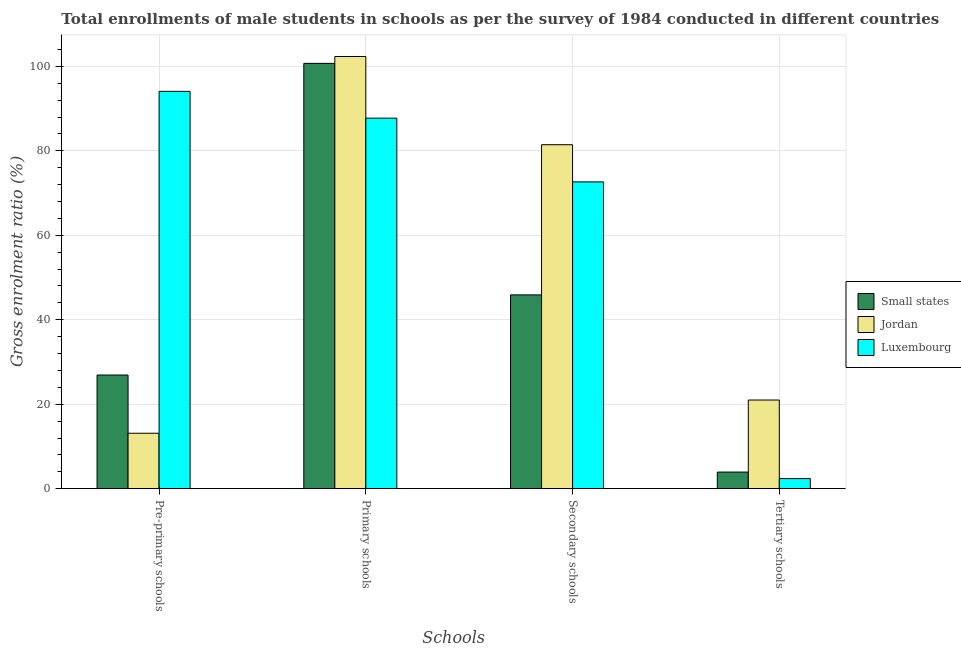How many groups of bars are there?
Give a very brief answer. 4. Are the number of bars per tick equal to the number of legend labels?
Provide a short and direct response. Yes. How many bars are there on the 4th tick from the left?
Provide a succinct answer. 3. How many bars are there on the 3rd tick from the right?
Offer a terse response. 3. What is the label of the 2nd group of bars from the left?
Your response must be concise. Primary schools. What is the gross enrolment ratio(male) in secondary schools in Luxembourg?
Provide a succinct answer. 72.65. Across all countries, what is the maximum gross enrolment ratio(male) in pre-primary schools?
Your response must be concise. 94.09. Across all countries, what is the minimum gross enrolment ratio(male) in primary schools?
Provide a succinct answer. 87.74. In which country was the gross enrolment ratio(male) in pre-primary schools maximum?
Make the answer very short. Luxembourg. In which country was the gross enrolment ratio(male) in primary schools minimum?
Provide a short and direct response. Luxembourg. What is the total gross enrolment ratio(male) in secondary schools in the graph?
Offer a very short reply. 199.99. What is the difference between the gross enrolment ratio(male) in pre-primary schools in Jordan and that in Small states?
Keep it short and to the point. -13.79. What is the difference between the gross enrolment ratio(male) in pre-primary schools in Small states and the gross enrolment ratio(male) in secondary schools in Jordan?
Your answer should be compact. -54.54. What is the average gross enrolment ratio(male) in primary schools per country?
Ensure brevity in your answer.  96.94. What is the difference between the gross enrolment ratio(male) in primary schools and gross enrolment ratio(male) in secondary schools in Small states?
Keep it short and to the point. 54.82. In how many countries, is the gross enrolment ratio(male) in primary schools greater than 4 %?
Give a very brief answer. 3. What is the ratio of the gross enrolment ratio(male) in secondary schools in Luxembourg to that in Small states?
Your response must be concise. 1.58. Is the difference between the gross enrolment ratio(male) in tertiary schools in Luxembourg and Jordan greater than the difference between the gross enrolment ratio(male) in secondary schools in Luxembourg and Jordan?
Your response must be concise. No. What is the difference between the highest and the second highest gross enrolment ratio(male) in pre-primary schools?
Your answer should be compact. 67.18. What is the difference between the highest and the lowest gross enrolment ratio(male) in secondary schools?
Give a very brief answer. 35.56. Is it the case that in every country, the sum of the gross enrolment ratio(male) in pre-primary schools and gross enrolment ratio(male) in secondary schools is greater than the sum of gross enrolment ratio(male) in primary schools and gross enrolment ratio(male) in tertiary schools?
Keep it short and to the point. No. What does the 1st bar from the left in Primary schools represents?
Offer a terse response. Small states. What does the 2nd bar from the right in Tertiary schools represents?
Your answer should be compact. Jordan. Is it the case that in every country, the sum of the gross enrolment ratio(male) in pre-primary schools and gross enrolment ratio(male) in primary schools is greater than the gross enrolment ratio(male) in secondary schools?
Make the answer very short. Yes. Are the values on the major ticks of Y-axis written in scientific E-notation?
Provide a succinct answer. No. Does the graph contain grids?
Keep it short and to the point. Yes. How are the legend labels stacked?
Your answer should be compact. Vertical. What is the title of the graph?
Your answer should be compact. Total enrollments of male students in schools as per the survey of 1984 conducted in different countries. What is the label or title of the X-axis?
Make the answer very short. Schools. What is the label or title of the Y-axis?
Make the answer very short. Gross enrolment ratio (%). What is the Gross enrolment ratio (%) in Small states in Pre-primary schools?
Make the answer very short. 26.91. What is the Gross enrolment ratio (%) of Jordan in Pre-primary schools?
Your answer should be very brief. 13.13. What is the Gross enrolment ratio (%) in Luxembourg in Pre-primary schools?
Give a very brief answer. 94.09. What is the Gross enrolment ratio (%) in Small states in Primary schools?
Provide a short and direct response. 100.71. What is the Gross enrolment ratio (%) of Jordan in Primary schools?
Give a very brief answer. 102.35. What is the Gross enrolment ratio (%) of Luxembourg in Primary schools?
Give a very brief answer. 87.74. What is the Gross enrolment ratio (%) in Small states in Secondary schools?
Your response must be concise. 45.89. What is the Gross enrolment ratio (%) in Jordan in Secondary schools?
Keep it short and to the point. 81.45. What is the Gross enrolment ratio (%) of Luxembourg in Secondary schools?
Give a very brief answer. 72.65. What is the Gross enrolment ratio (%) of Small states in Tertiary schools?
Your answer should be compact. 3.93. What is the Gross enrolment ratio (%) of Jordan in Tertiary schools?
Offer a terse response. 21. What is the Gross enrolment ratio (%) in Luxembourg in Tertiary schools?
Give a very brief answer. 2.39. Across all Schools, what is the maximum Gross enrolment ratio (%) of Small states?
Ensure brevity in your answer.  100.71. Across all Schools, what is the maximum Gross enrolment ratio (%) of Jordan?
Offer a very short reply. 102.35. Across all Schools, what is the maximum Gross enrolment ratio (%) of Luxembourg?
Ensure brevity in your answer.  94.09. Across all Schools, what is the minimum Gross enrolment ratio (%) in Small states?
Your answer should be very brief. 3.93. Across all Schools, what is the minimum Gross enrolment ratio (%) in Jordan?
Make the answer very short. 13.13. Across all Schools, what is the minimum Gross enrolment ratio (%) in Luxembourg?
Your answer should be compact. 2.39. What is the total Gross enrolment ratio (%) of Small states in the graph?
Give a very brief answer. 177.45. What is the total Gross enrolment ratio (%) in Jordan in the graph?
Provide a succinct answer. 217.92. What is the total Gross enrolment ratio (%) in Luxembourg in the graph?
Your answer should be very brief. 256.87. What is the difference between the Gross enrolment ratio (%) in Small states in Pre-primary schools and that in Primary schools?
Make the answer very short. -73.8. What is the difference between the Gross enrolment ratio (%) in Jordan in Pre-primary schools and that in Primary schools?
Provide a short and direct response. -89.22. What is the difference between the Gross enrolment ratio (%) in Luxembourg in Pre-primary schools and that in Primary schools?
Your answer should be compact. 6.35. What is the difference between the Gross enrolment ratio (%) in Small states in Pre-primary schools and that in Secondary schools?
Make the answer very short. -18.98. What is the difference between the Gross enrolment ratio (%) in Jordan in Pre-primary schools and that in Secondary schools?
Offer a very short reply. -68.33. What is the difference between the Gross enrolment ratio (%) in Luxembourg in Pre-primary schools and that in Secondary schools?
Offer a very short reply. 21.44. What is the difference between the Gross enrolment ratio (%) of Small states in Pre-primary schools and that in Tertiary schools?
Your answer should be very brief. 22.98. What is the difference between the Gross enrolment ratio (%) of Jordan in Pre-primary schools and that in Tertiary schools?
Your response must be concise. -7.87. What is the difference between the Gross enrolment ratio (%) of Luxembourg in Pre-primary schools and that in Tertiary schools?
Provide a succinct answer. 91.7. What is the difference between the Gross enrolment ratio (%) of Small states in Primary schools and that in Secondary schools?
Your response must be concise. 54.82. What is the difference between the Gross enrolment ratio (%) of Jordan in Primary schools and that in Secondary schools?
Provide a short and direct response. 20.89. What is the difference between the Gross enrolment ratio (%) in Luxembourg in Primary schools and that in Secondary schools?
Keep it short and to the point. 15.1. What is the difference between the Gross enrolment ratio (%) of Small states in Primary schools and that in Tertiary schools?
Your answer should be compact. 96.78. What is the difference between the Gross enrolment ratio (%) in Jordan in Primary schools and that in Tertiary schools?
Keep it short and to the point. 81.35. What is the difference between the Gross enrolment ratio (%) of Luxembourg in Primary schools and that in Tertiary schools?
Your answer should be compact. 85.36. What is the difference between the Gross enrolment ratio (%) in Small states in Secondary schools and that in Tertiary schools?
Offer a very short reply. 41.96. What is the difference between the Gross enrolment ratio (%) in Jordan in Secondary schools and that in Tertiary schools?
Offer a terse response. 60.46. What is the difference between the Gross enrolment ratio (%) in Luxembourg in Secondary schools and that in Tertiary schools?
Provide a succinct answer. 70.26. What is the difference between the Gross enrolment ratio (%) in Small states in Pre-primary schools and the Gross enrolment ratio (%) in Jordan in Primary schools?
Make the answer very short. -75.43. What is the difference between the Gross enrolment ratio (%) of Small states in Pre-primary schools and the Gross enrolment ratio (%) of Luxembourg in Primary schools?
Provide a succinct answer. -60.83. What is the difference between the Gross enrolment ratio (%) of Jordan in Pre-primary schools and the Gross enrolment ratio (%) of Luxembourg in Primary schools?
Make the answer very short. -74.62. What is the difference between the Gross enrolment ratio (%) of Small states in Pre-primary schools and the Gross enrolment ratio (%) of Jordan in Secondary schools?
Make the answer very short. -54.54. What is the difference between the Gross enrolment ratio (%) of Small states in Pre-primary schools and the Gross enrolment ratio (%) of Luxembourg in Secondary schools?
Your answer should be compact. -45.73. What is the difference between the Gross enrolment ratio (%) in Jordan in Pre-primary schools and the Gross enrolment ratio (%) in Luxembourg in Secondary schools?
Your answer should be compact. -59.52. What is the difference between the Gross enrolment ratio (%) in Small states in Pre-primary schools and the Gross enrolment ratio (%) in Jordan in Tertiary schools?
Make the answer very short. 5.92. What is the difference between the Gross enrolment ratio (%) in Small states in Pre-primary schools and the Gross enrolment ratio (%) in Luxembourg in Tertiary schools?
Give a very brief answer. 24.53. What is the difference between the Gross enrolment ratio (%) of Jordan in Pre-primary schools and the Gross enrolment ratio (%) of Luxembourg in Tertiary schools?
Offer a very short reply. 10.74. What is the difference between the Gross enrolment ratio (%) of Small states in Primary schools and the Gross enrolment ratio (%) of Jordan in Secondary schools?
Ensure brevity in your answer.  19.26. What is the difference between the Gross enrolment ratio (%) in Small states in Primary schools and the Gross enrolment ratio (%) in Luxembourg in Secondary schools?
Your answer should be compact. 28.06. What is the difference between the Gross enrolment ratio (%) in Jordan in Primary schools and the Gross enrolment ratio (%) in Luxembourg in Secondary schools?
Your answer should be compact. 29.7. What is the difference between the Gross enrolment ratio (%) in Small states in Primary schools and the Gross enrolment ratio (%) in Jordan in Tertiary schools?
Your answer should be very brief. 79.72. What is the difference between the Gross enrolment ratio (%) of Small states in Primary schools and the Gross enrolment ratio (%) of Luxembourg in Tertiary schools?
Ensure brevity in your answer.  98.33. What is the difference between the Gross enrolment ratio (%) in Jordan in Primary schools and the Gross enrolment ratio (%) in Luxembourg in Tertiary schools?
Ensure brevity in your answer.  99.96. What is the difference between the Gross enrolment ratio (%) in Small states in Secondary schools and the Gross enrolment ratio (%) in Jordan in Tertiary schools?
Offer a very short reply. 24.9. What is the difference between the Gross enrolment ratio (%) of Small states in Secondary schools and the Gross enrolment ratio (%) of Luxembourg in Tertiary schools?
Ensure brevity in your answer.  43.5. What is the difference between the Gross enrolment ratio (%) of Jordan in Secondary schools and the Gross enrolment ratio (%) of Luxembourg in Tertiary schools?
Offer a very short reply. 79.07. What is the average Gross enrolment ratio (%) of Small states per Schools?
Offer a very short reply. 44.36. What is the average Gross enrolment ratio (%) of Jordan per Schools?
Offer a terse response. 54.48. What is the average Gross enrolment ratio (%) in Luxembourg per Schools?
Give a very brief answer. 64.22. What is the difference between the Gross enrolment ratio (%) in Small states and Gross enrolment ratio (%) in Jordan in Pre-primary schools?
Make the answer very short. 13.79. What is the difference between the Gross enrolment ratio (%) of Small states and Gross enrolment ratio (%) of Luxembourg in Pre-primary schools?
Keep it short and to the point. -67.18. What is the difference between the Gross enrolment ratio (%) of Jordan and Gross enrolment ratio (%) of Luxembourg in Pre-primary schools?
Provide a succinct answer. -80.97. What is the difference between the Gross enrolment ratio (%) in Small states and Gross enrolment ratio (%) in Jordan in Primary schools?
Offer a very short reply. -1.64. What is the difference between the Gross enrolment ratio (%) in Small states and Gross enrolment ratio (%) in Luxembourg in Primary schools?
Ensure brevity in your answer.  12.97. What is the difference between the Gross enrolment ratio (%) in Jordan and Gross enrolment ratio (%) in Luxembourg in Primary schools?
Give a very brief answer. 14.6. What is the difference between the Gross enrolment ratio (%) of Small states and Gross enrolment ratio (%) of Jordan in Secondary schools?
Offer a terse response. -35.56. What is the difference between the Gross enrolment ratio (%) of Small states and Gross enrolment ratio (%) of Luxembourg in Secondary schools?
Your answer should be compact. -26.76. What is the difference between the Gross enrolment ratio (%) in Jordan and Gross enrolment ratio (%) in Luxembourg in Secondary schools?
Your response must be concise. 8.81. What is the difference between the Gross enrolment ratio (%) of Small states and Gross enrolment ratio (%) of Jordan in Tertiary schools?
Ensure brevity in your answer.  -17.06. What is the difference between the Gross enrolment ratio (%) in Small states and Gross enrolment ratio (%) in Luxembourg in Tertiary schools?
Provide a succinct answer. 1.55. What is the difference between the Gross enrolment ratio (%) of Jordan and Gross enrolment ratio (%) of Luxembourg in Tertiary schools?
Ensure brevity in your answer.  18.61. What is the ratio of the Gross enrolment ratio (%) in Small states in Pre-primary schools to that in Primary schools?
Offer a terse response. 0.27. What is the ratio of the Gross enrolment ratio (%) of Jordan in Pre-primary schools to that in Primary schools?
Your answer should be compact. 0.13. What is the ratio of the Gross enrolment ratio (%) of Luxembourg in Pre-primary schools to that in Primary schools?
Offer a terse response. 1.07. What is the ratio of the Gross enrolment ratio (%) in Small states in Pre-primary schools to that in Secondary schools?
Make the answer very short. 0.59. What is the ratio of the Gross enrolment ratio (%) in Jordan in Pre-primary schools to that in Secondary schools?
Ensure brevity in your answer.  0.16. What is the ratio of the Gross enrolment ratio (%) of Luxembourg in Pre-primary schools to that in Secondary schools?
Keep it short and to the point. 1.3. What is the ratio of the Gross enrolment ratio (%) of Small states in Pre-primary schools to that in Tertiary schools?
Provide a succinct answer. 6.84. What is the ratio of the Gross enrolment ratio (%) of Jordan in Pre-primary schools to that in Tertiary schools?
Make the answer very short. 0.63. What is the ratio of the Gross enrolment ratio (%) in Luxembourg in Pre-primary schools to that in Tertiary schools?
Your answer should be very brief. 39.4. What is the ratio of the Gross enrolment ratio (%) in Small states in Primary schools to that in Secondary schools?
Provide a succinct answer. 2.19. What is the ratio of the Gross enrolment ratio (%) of Jordan in Primary schools to that in Secondary schools?
Ensure brevity in your answer.  1.26. What is the ratio of the Gross enrolment ratio (%) in Luxembourg in Primary schools to that in Secondary schools?
Provide a succinct answer. 1.21. What is the ratio of the Gross enrolment ratio (%) in Small states in Primary schools to that in Tertiary schools?
Your answer should be compact. 25.6. What is the ratio of the Gross enrolment ratio (%) of Jordan in Primary schools to that in Tertiary schools?
Ensure brevity in your answer.  4.87. What is the ratio of the Gross enrolment ratio (%) of Luxembourg in Primary schools to that in Tertiary schools?
Give a very brief answer. 36.75. What is the ratio of the Gross enrolment ratio (%) of Small states in Secondary schools to that in Tertiary schools?
Your answer should be very brief. 11.67. What is the ratio of the Gross enrolment ratio (%) of Jordan in Secondary schools to that in Tertiary schools?
Make the answer very short. 3.88. What is the ratio of the Gross enrolment ratio (%) of Luxembourg in Secondary schools to that in Tertiary schools?
Provide a short and direct response. 30.42. What is the difference between the highest and the second highest Gross enrolment ratio (%) of Small states?
Provide a short and direct response. 54.82. What is the difference between the highest and the second highest Gross enrolment ratio (%) in Jordan?
Give a very brief answer. 20.89. What is the difference between the highest and the second highest Gross enrolment ratio (%) of Luxembourg?
Give a very brief answer. 6.35. What is the difference between the highest and the lowest Gross enrolment ratio (%) of Small states?
Offer a very short reply. 96.78. What is the difference between the highest and the lowest Gross enrolment ratio (%) of Jordan?
Ensure brevity in your answer.  89.22. What is the difference between the highest and the lowest Gross enrolment ratio (%) of Luxembourg?
Provide a short and direct response. 91.7. 